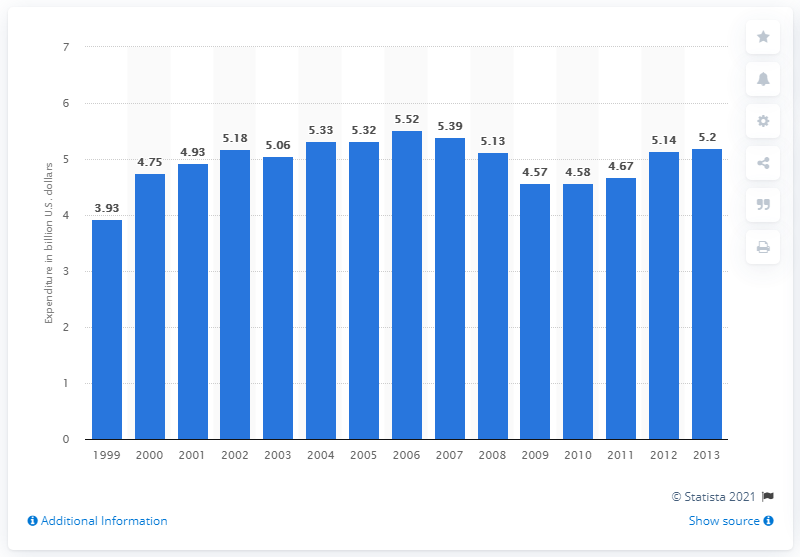Highlight a few significant elements in this photo. In 2013, the amount of money spent by consumers on musical instruments in the United States was approximately 5.2 billion dollars. 